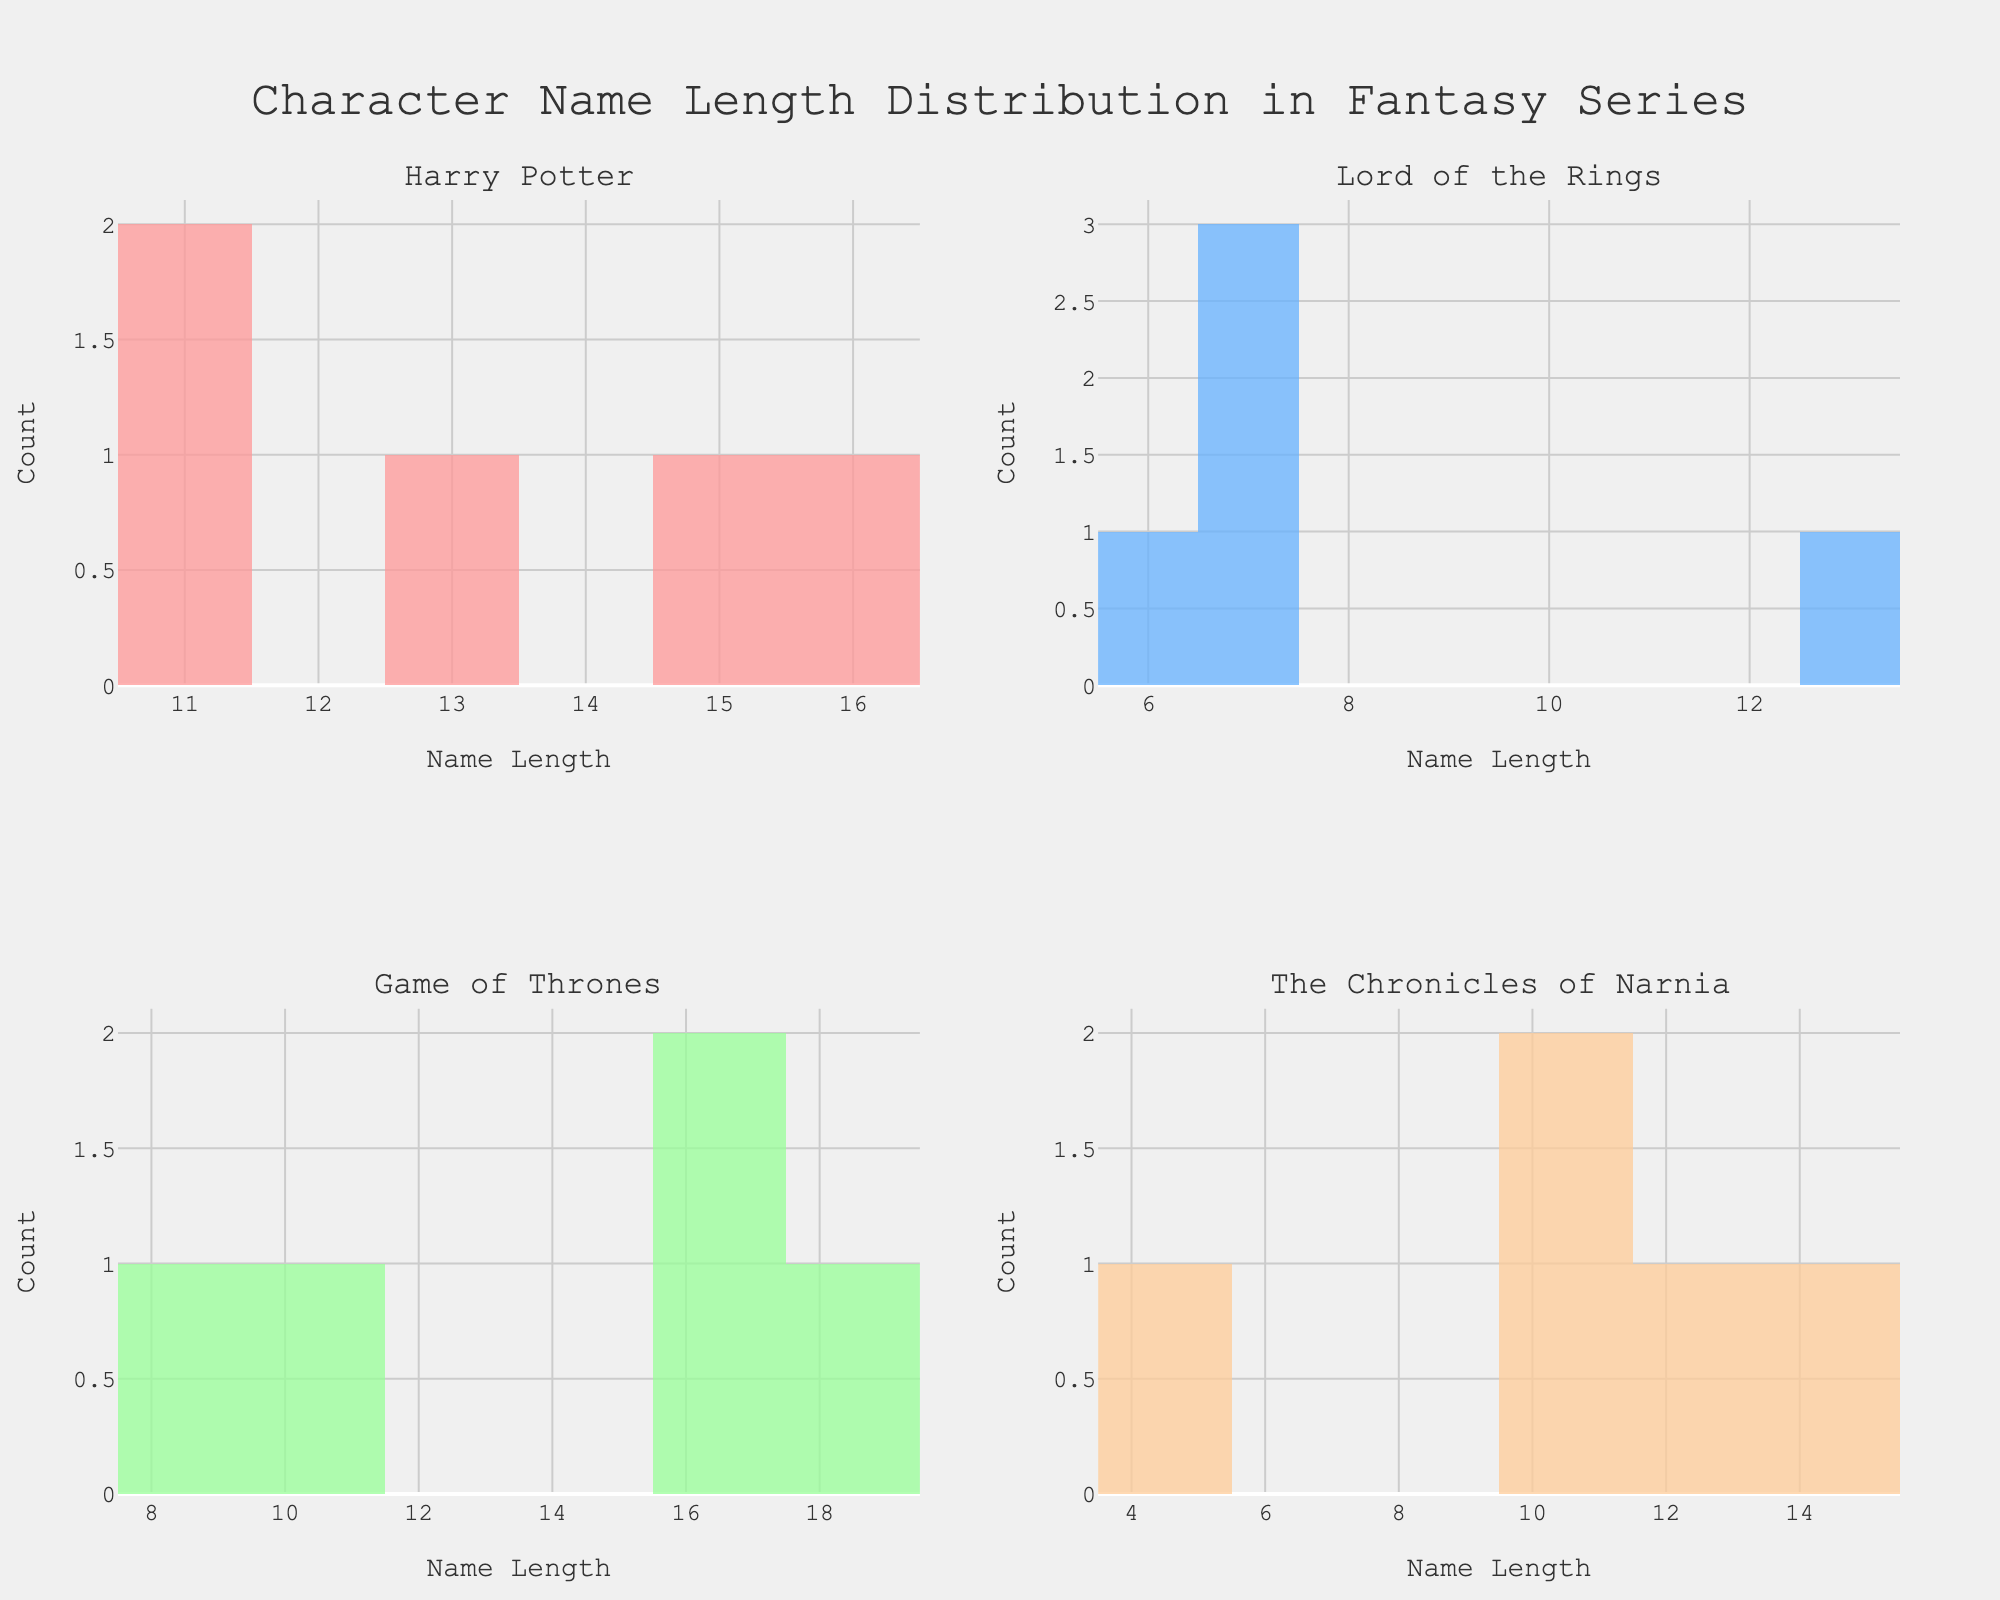What's the title of the figure? The title of the figure is typically displayed prominently at the top of the plot area. It provides a summary of what the figure represents. In this case, the title is displayed at the top center of the figure.
Answer: Character Name Length Distribution in Fantasy Series What are the series names that are being compared? Each subplot has a title that indicates the series whose character name lengths are being analyzed. There are four subplots, each representing a different series.
Answer: Harry Potter, Lord of the Rings, Game of Thrones, The Chronicles of Narnia How many characters from 'Harry Potter' have name lengths of 11? In the 'Harry Potter' subplot, there is a bar representing name lengths of 11. The height of this bar indicates the count of characters with that name length.
Answer: 2 Which series has the character with the shortest name length, and what is the length? By observing the shortest bar in each subplot, we can identify which series has the shortest name length and then check the length on the x-axis. The shortest name length among the series is 5.
Answer: The Chronicles of Narnia, 5 In the 'Game of Thrones' subplot, what is the difference in count between the longest and shortest character name lengths? In the 'Game of Thrones' subplot, the longest name length is 18 and the shortest is around 8. By comparing the heights of the bars, we can determine their respective counts and calculate the difference.
Answer: 1 Which series has the most varied (widest range) character name lengths? To determine this, observe each subplot and identify the range by noting the minimum and maximum name lengths. The largest difference between these values indicates the widest range.
Answer: Game of Thrones In the 'Lord of the Rings' subplot, how many characters have name lengths greater than 10? We need to look for bars in the 'Lord of the Rings' subplot that correspond to name lengths greater than 10 and sum the counts represented by these bars.
Answer: 1 What's the median name length for characters from 'The Chronicles of Narnia'? To find the median, we need to list the name lengths of all characters from 'The Chronicles of Narnia' in ascending order and find the middle value.
Answer: 11 Which two series have the most similar distribution of character name lengths? This involves visually comparing the histograms of each series to identify which two have bars of similar heights at similar name lengths.
Answer: Lord of the Rings and The Chronicles of Narnia 